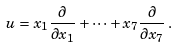<formula> <loc_0><loc_0><loc_500><loc_500>u = x _ { 1 } \frac { \partial } { \partial x _ { 1 } } + \dots + x _ { 7 } \frac { \partial } { \partial x _ { 7 } } \, .</formula> 